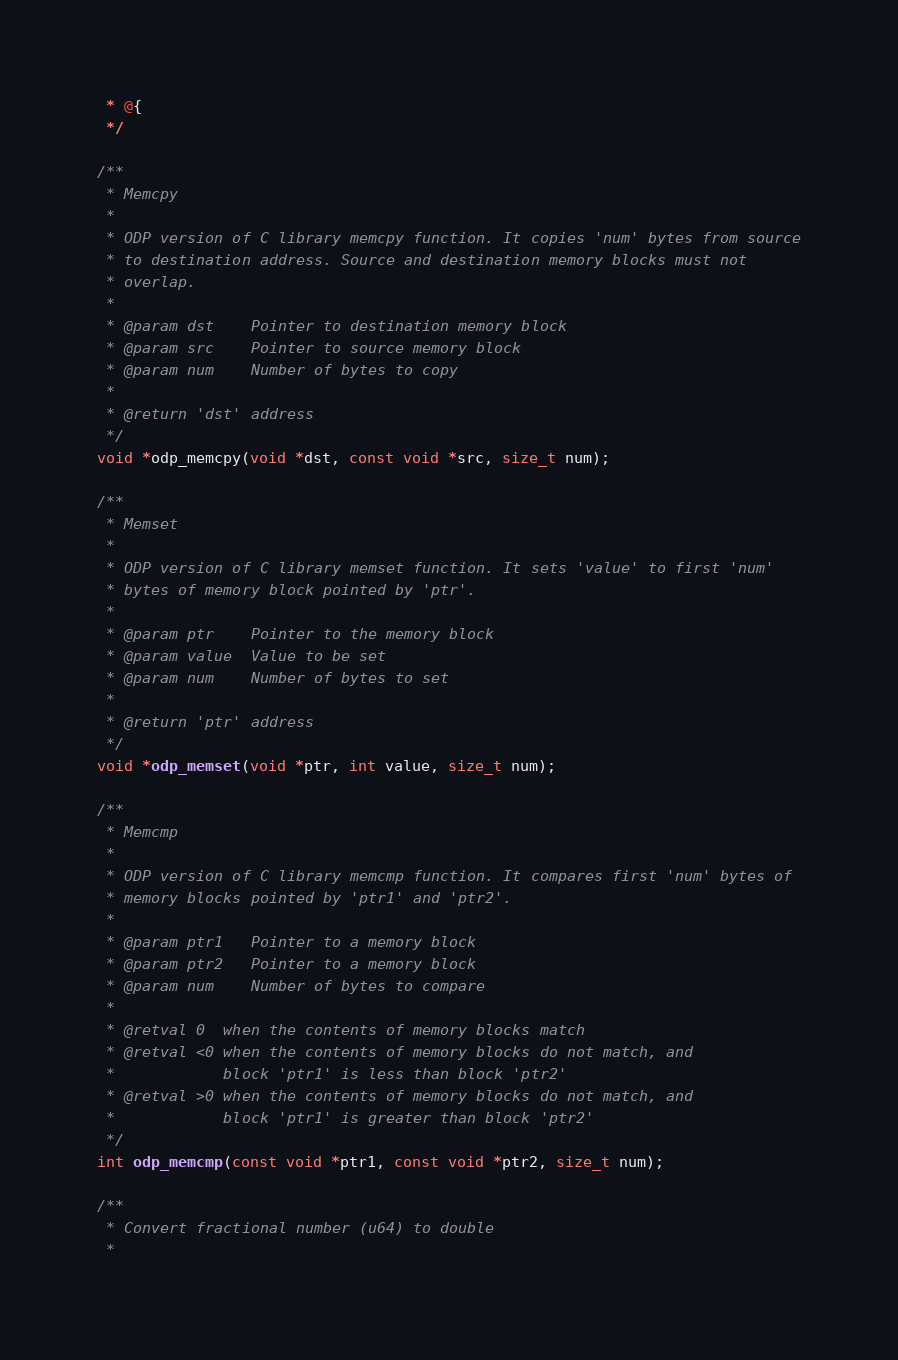Convert code to text. <code><loc_0><loc_0><loc_500><loc_500><_C_> * @{
 */

/**
 * Memcpy
 *
 * ODP version of C library memcpy function. It copies 'num' bytes from source
 * to destination address. Source and destination memory blocks must not
 * overlap.
 *
 * @param dst    Pointer to destination memory block
 * @param src    Pointer to source memory block
 * @param num    Number of bytes to copy
 *
 * @return 'dst' address
 */
void *odp_memcpy(void *dst, const void *src, size_t num);

/**
 * Memset
 *
 * ODP version of C library memset function. It sets 'value' to first 'num'
 * bytes of memory block pointed by 'ptr'.
 *
 * @param ptr    Pointer to the memory block
 * @param value  Value to be set
 * @param num    Number of bytes to set
 *
 * @return 'ptr' address
 */
void *odp_memset(void *ptr, int value, size_t num);

/**
 * Memcmp
 *
 * ODP version of C library memcmp function. It compares first 'num' bytes of
 * memory blocks pointed by 'ptr1' and 'ptr2'.
 *
 * @param ptr1   Pointer to a memory block
 * @param ptr2   Pointer to a memory block
 * @param num    Number of bytes to compare
 *
 * @retval 0  when the contents of memory blocks match
 * @retval <0 when the contents of memory blocks do not match, and
 *            block 'ptr1' is less than block 'ptr2'
 * @retval >0 when the contents of memory blocks do not match, and
 *            block 'ptr1' is greater than block 'ptr2'
 */
int odp_memcmp(const void *ptr1, const void *ptr2, size_t num);

/**
 * Convert fractional number (u64) to double
 *</code> 